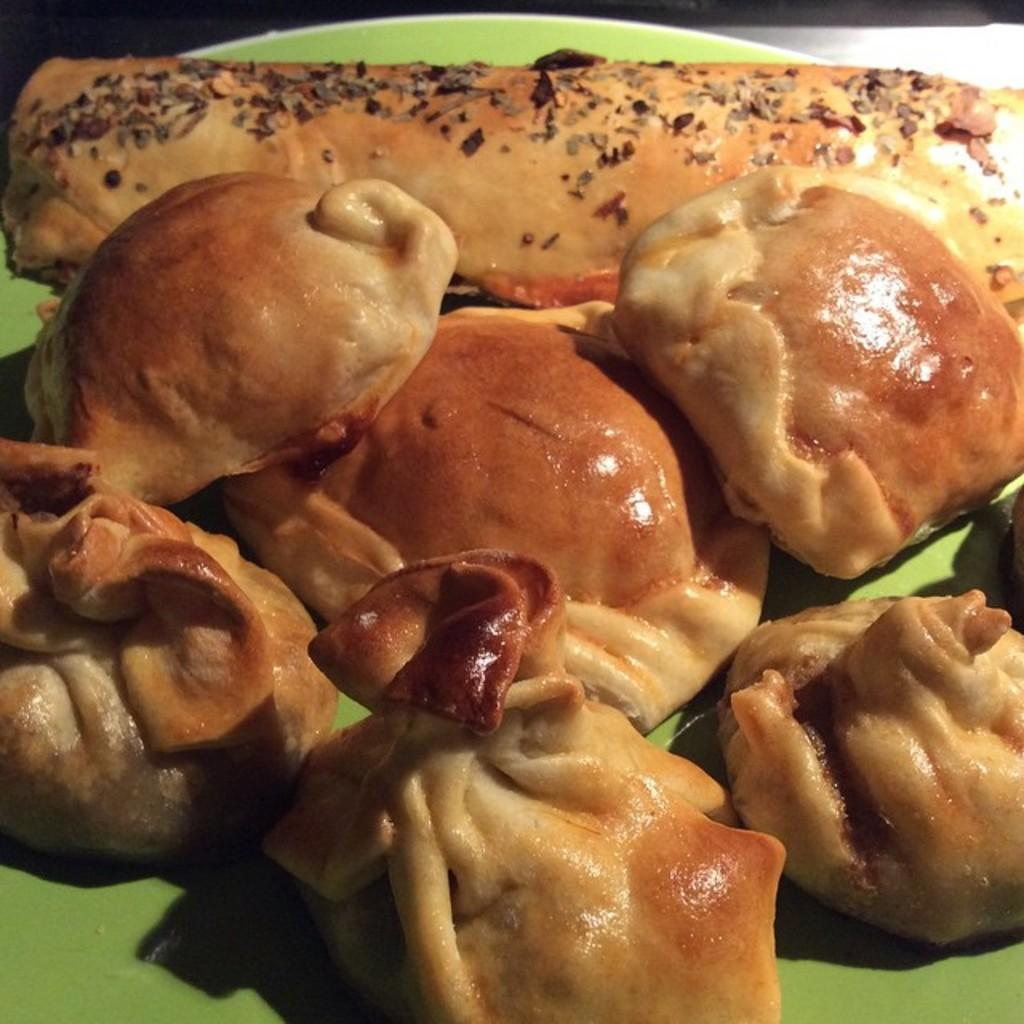What is on the plate that is visible in the image? There are food items on a plate in the image. What is the color of the plate? The plate is green in color. What type of cloud is visible in the image? There is no cloud visible in the image, as it only features a plate with food items and a green plate. 